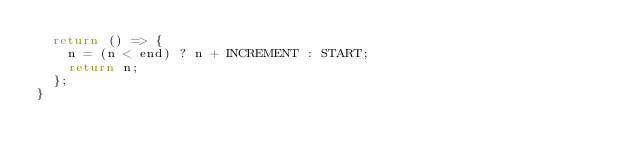Convert code to text. <code><loc_0><loc_0><loc_500><loc_500><_TypeScript_>  return () => {
    n = (n < end) ? n + INCREMENT : START;
    return n;
  };
}
</code> 